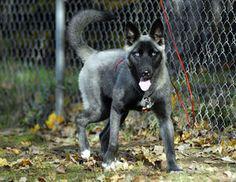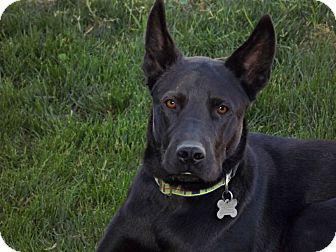The first image is the image on the left, the second image is the image on the right. For the images shown, is this caption "There are two dogs together outside in the image on the left." true? Answer yes or no. No. The first image is the image on the left, the second image is the image on the right. For the images displayed, is the sentence "There are at least two dogs in the left image." factually correct? Answer yes or no. No. 